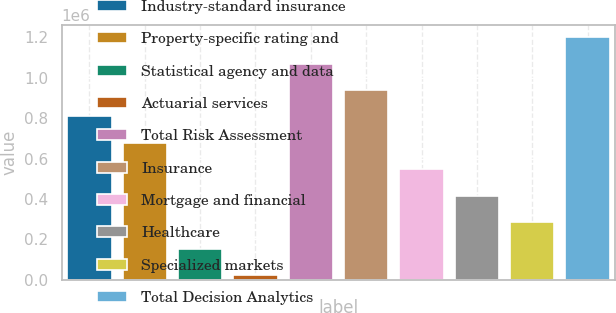Convert chart to OTSL. <chart><loc_0><loc_0><loc_500><loc_500><bar_chart><fcel>Industry-standard insurance<fcel>Property-specific rating and<fcel>Statistical agency and data<fcel>Actuarial services<fcel>Total Risk Assessment<fcel>Insurance<fcel>Mortgage and financial<fcel>Healthcare<fcel>Specialized markets<fcel>Total Decision Analytics<nl><fcel>808230<fcel>677328<fcel>153718<fcel>22816<fcel>1.07004e+06<fcel>939133<fcel>546426<fcel>415523<fcel>284621<fcel>1.20094e+06<nl></chart> 